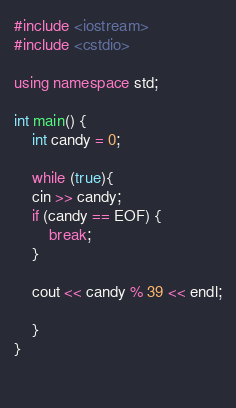<code> <loc_0><loc_0><loc_500><loc_500><_C++_>#include <iostream>
#include <cstdio>

using namespace std;
 
int main() {
    int candy = 0;
       
    while (true){
    cin >> candy;
    if (candy == EOF) {
        break;
    }
     
    cout << candy % 39 << endl;
     
    }
}
 
 </code> 